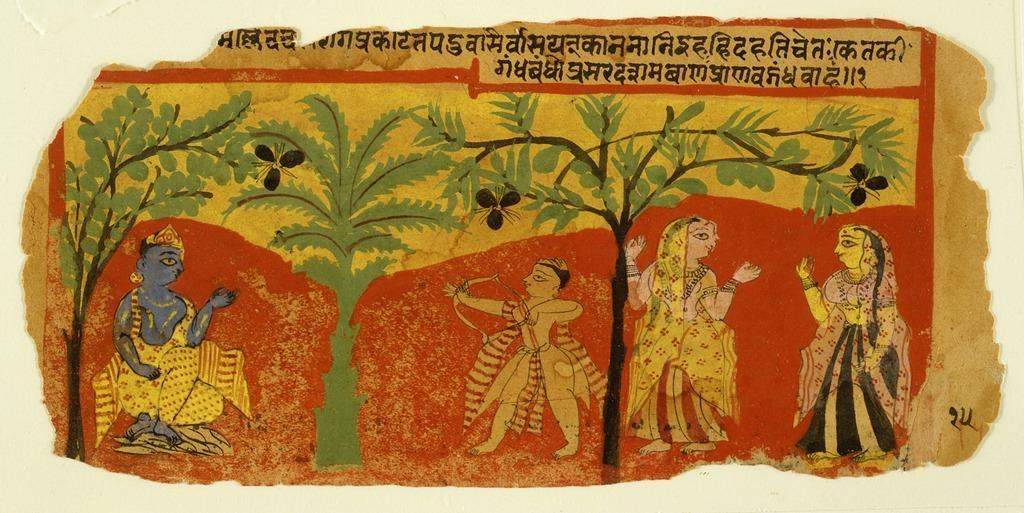How would you summarize this image in a sentence or two? In this image there is a poster on the wall, where there are people, trees, letters and numbers on the poster. 